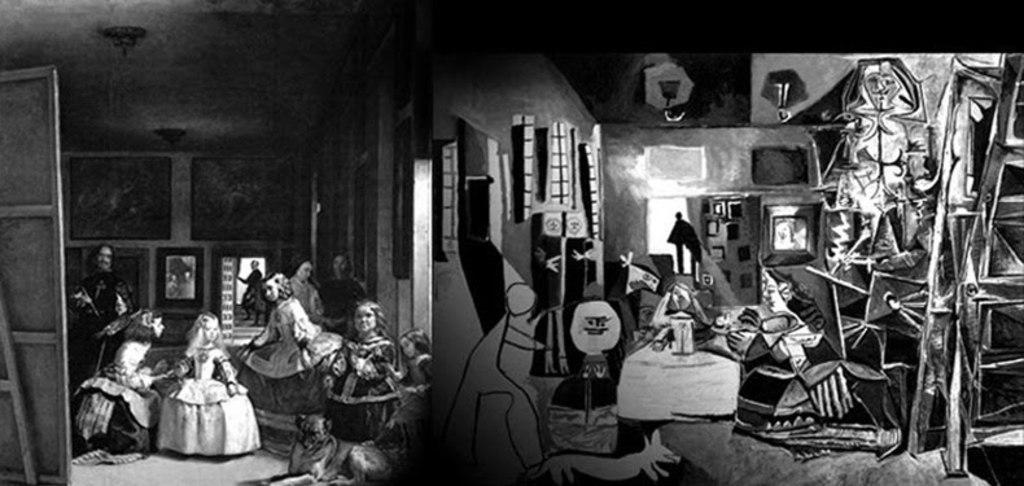In one or two sentences, can you explain what this image depicts? This is a white and black image. In this picture we can see a few dolls. There is a person at the back. We can see a few frames on the wall. We can see art crafts. There are wooden objects on the right and left side of the image. 